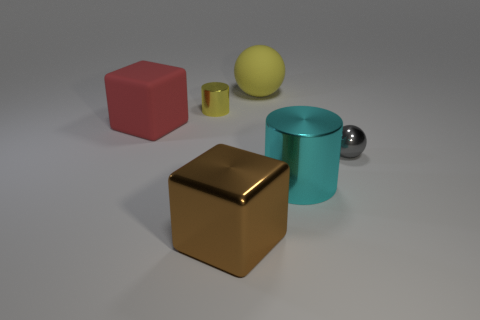Is there a large red metal ball?
Provide a succinct answer. No. There is a ball that is the same material as the large cylinder; what color is it?
Your answer should be compact. Gray. The tiny object that is to the left of the shiny cylinder that is right of the small thing that is behind the gray object is what color?
Your response must be concise. Yellow. There is a gray metal thing; is it the same size as the ball that is on the left side of the gray thing?
Give a very brief answer. No. How many things are either gray metallic objects in front of the large red matte cube or tiny metallic objects that are on the right side of the tiny yellow metallic cylinder?
Your response must be concise. 1. There is a yellow thing that is the same size as the cyan thing; what is its shape?
Make the answer very short. Sphere. There is a large shiny object on the right side of the ball behind the small gray metallic thing in front of the yellow metal cylinder; what shape is it?
Ensure brevity in your answer.  Cylinder. Is the number of big brown objects behind the large rubber cube the same as the number of gray balls?
Your answer should be compact. No. Do the metal sphere and the red rubber cube have the same size?
Offer a terse response. No. How many matte things are red things or spheres?
Provide a short and direct response. 2. 